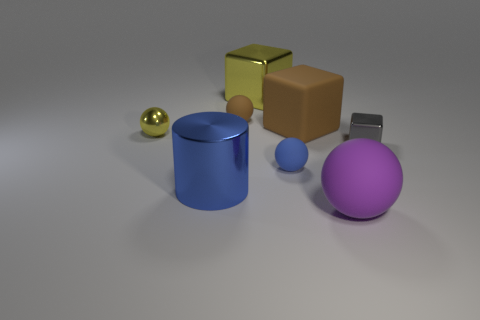What is the material of the big purple ball?
Keep it short and to the point. Rubber. What number of things are yellow cubes or cyan cylinders?
Keep it short and to the point. 1. There is a shiny thing right of the big purple sphere; does it have the same size as the yellow metallic object that is to the left of the large cylinder?
Provide a short and direct response. Yes. How many other things are the same size as the blue matte object?
Offer a terse response. 3. How many things are either balls that are on the right side of the blue shiny object or metallic objects that are behind the brown matte sphere?
Provide a short and direct response. 4. Are the big yellow block and the cube that is on the right side of the purple matte ball made of the same material?
Offer a terse response. Yes. What number of other things are the same shape as the small blue object?
Ensure brevity in your answer.  3. What is the material of the tiny sphere that is in front of the metallic object right of the big rubber thing in front of the tiny yellow ball?
Make the answer very short. Rubber. Are there the same number of large yellow metal things that are behind the yellow cube and tiny green cylinders?
Provide a succinct answer. Yes. Does the brown object that is behind the large brown block have the same material as the small sphere that is in front of the small shiny block?
Offer a terse response. Yes. 